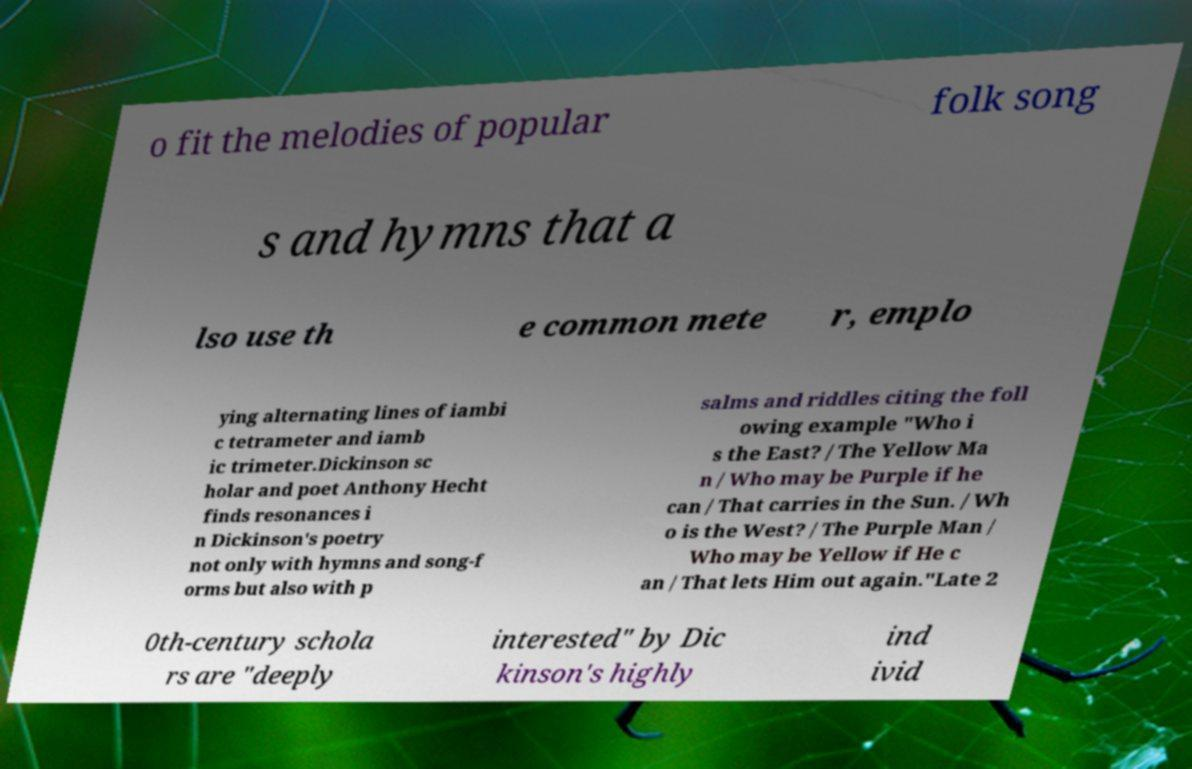Please identify and transcribe the text found in this image. o fit the melodies of popular folk song s and hymns that a lso use th e common mete r, emplo ying alternating lines of iambi c tetrameter and iamb ic trimeter.Dickinson sc holar and poet Anthony Hecht finds resonances i n Dickinson's poetry not only with hymns and song-f orms but also with p salms and riddles citing the foll owing example "Who i s the East? / The Yellow Ma n / Who may be Purple if he can / That carries in the Sun. / Wh o is the West? / The Purple Man / Who may be Yellow if He c an / That lets Him out again."Late 2 0th-century schola rs are "deeply interested" by Dic kinson's highly ind ivid 